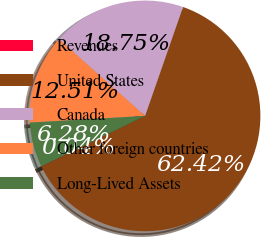Convert chart. <chart><loc_0><loc_0><loc_500><loc_500><pie_chart><fcel>Revenues<fcel>United States<fcel>Canada<fcel>Other foreign countries<fcel>Long-Lived Assets<nl><fcel>0.04%<fcel>62.42%<fcel>18.75%<fcel>12.51%<fcel>6.28%<nl></chart> 